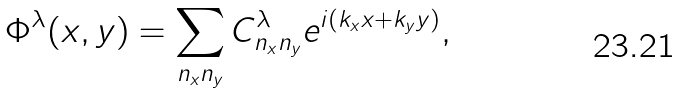<formula> <loc_0><loc_0><loc_500><loc_500>\Phi ^ { \lambda } ( x , y ) = \sum _ { n _ { x } n _ { y } } C ^ { \lambda } _ { n _ { x } n _ { y } } e ^ { i ( k _ { x } x + k _ { y } y ) } ,</formula> 